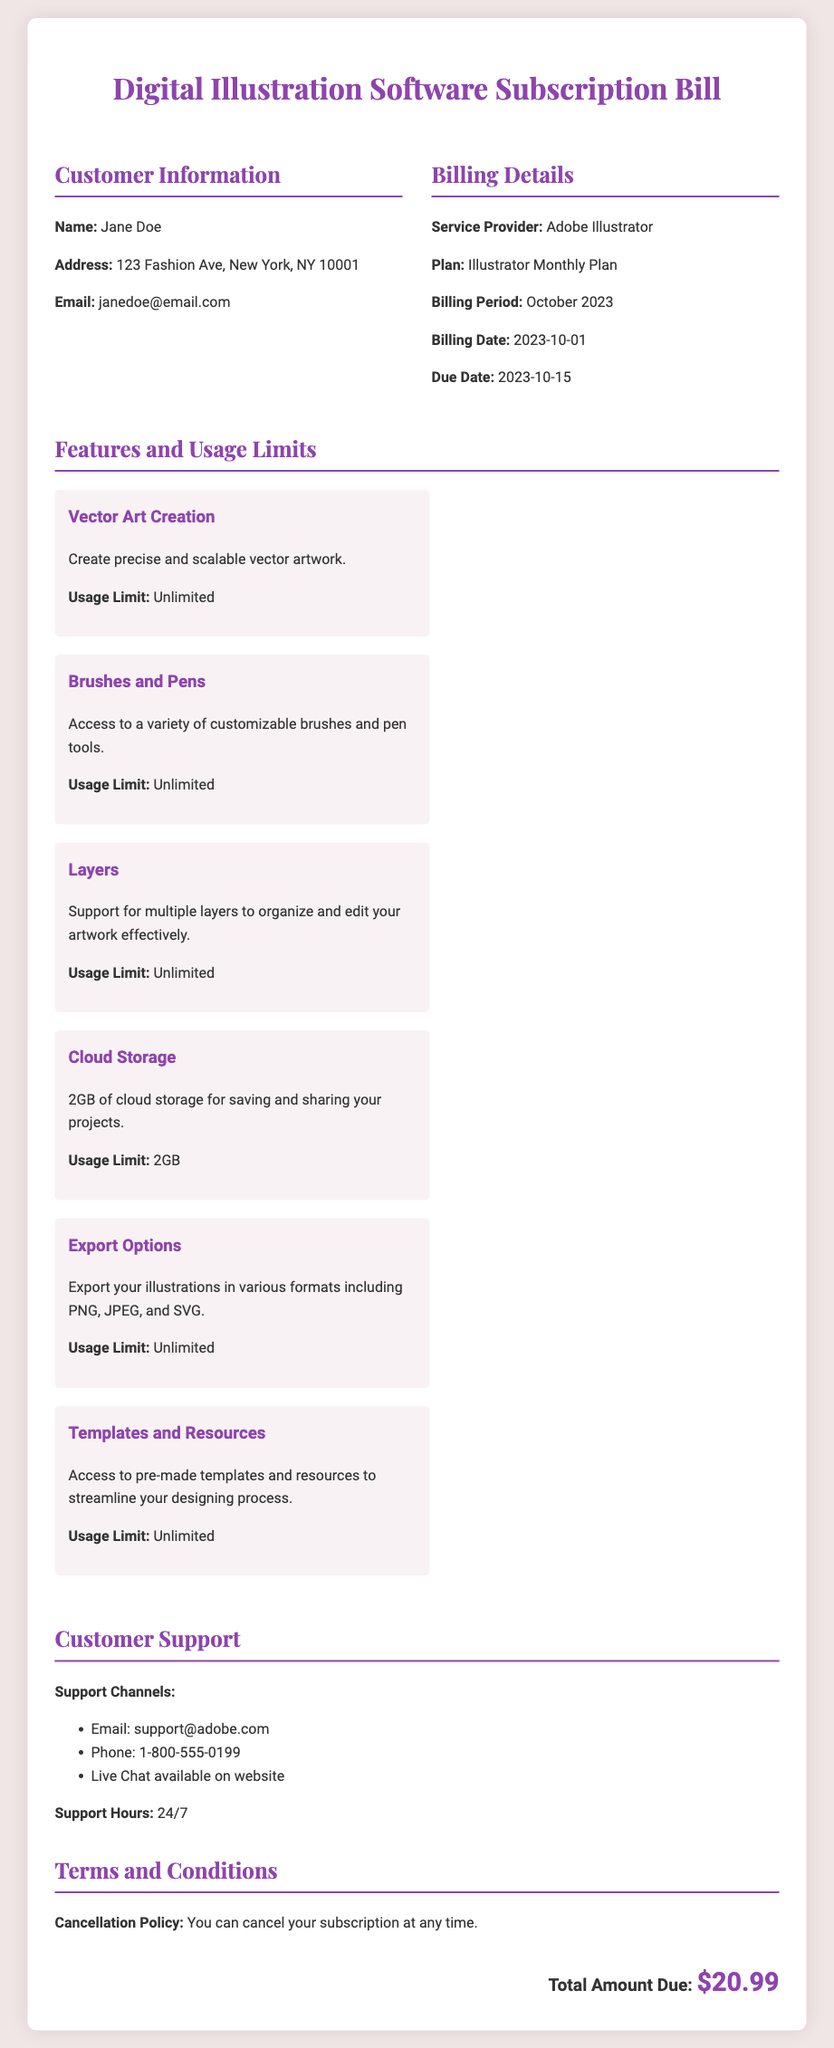What is the customer's name? The document clearly states the customer's name in the Customer Information section.
Answer: Jane Doe What is the billing date? The billing date is found in the Billing Details section, specifying when the bill was issued.
Answer: 2023-10-01 What is the total amount due? The total amount due is mentioned at the end of the document, indicating how much the customer needs to pay.
Answer: $20.99 How much cloud storage is provided? The document specifies the amount of cloud storage included in the features.
Answer: 2GB What is the cancellation policy? The cancellation policy is outlined in the Terms and Conditions, stating the customer's ability to cancel.
Answer: You can cancel your subscription at any time What types of illustrations can be exported? The document lists the formats available for exporting illustrations within the Export Options section.
Answer: PNG, JPEG, and SVG What is the support phone number? The customer's support phone number is provided in the Customer Support section of the document.
Answer: 1-800-555-0199 How often is the subscription billed? This information relates to the billing plan mentioned in the document, referring to its frequency.
Answer: Monthly What feature allows for multiple design layers? The document specifies a feature that supports this capability, indicating its role in artwork organization.
Answer: Layers 